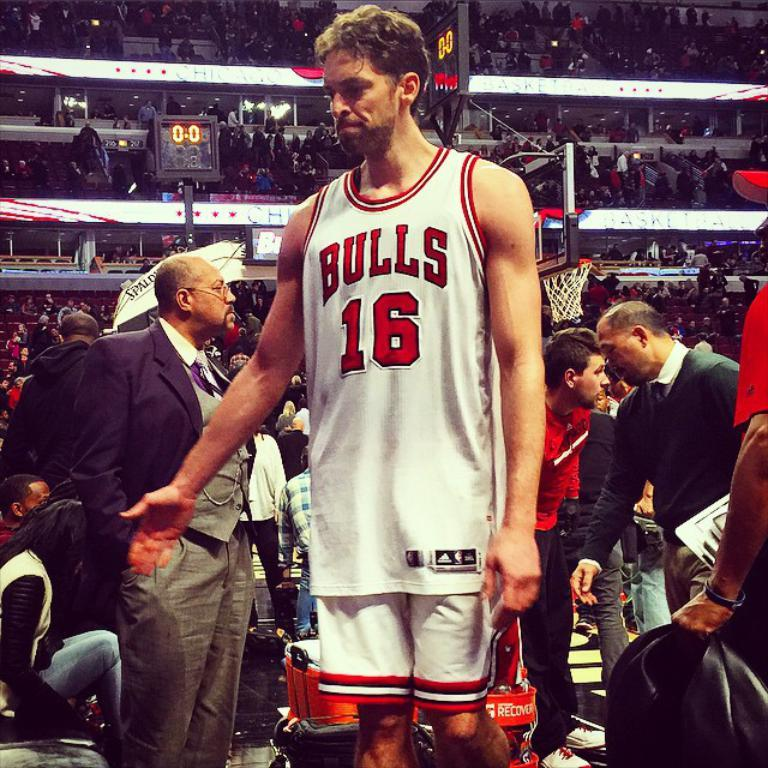<image>
Give a short and clear explanation of the subsequent image. A player for the Bulls stands in a crowd of people 